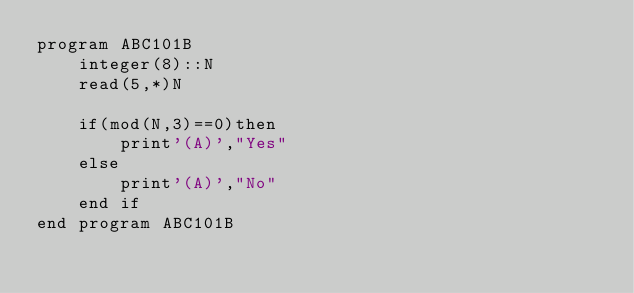<code> <loc_0><loc_0><loc_500><loc_500><_FORTRAN_>program ABC101B
	integer(8)::N
	read(5,*)N
	
	if(mod(N,3)==0)then
		print'(A)',"Yes"
	else
		print'(A)',"No"
	end if
end program ABC101B
</code> 